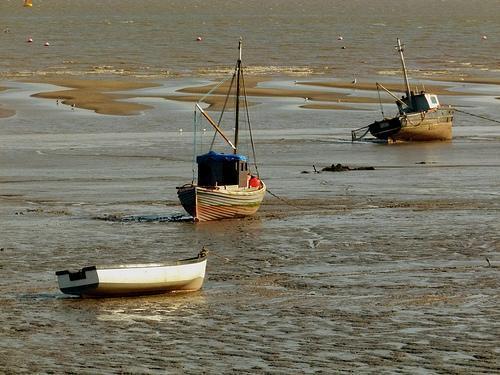How many empty boats?
Give a very brief answer. 1. 